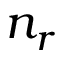<formula> <loc_0><loc_0><loc_500><loc_500>n _ { r }</formula> 